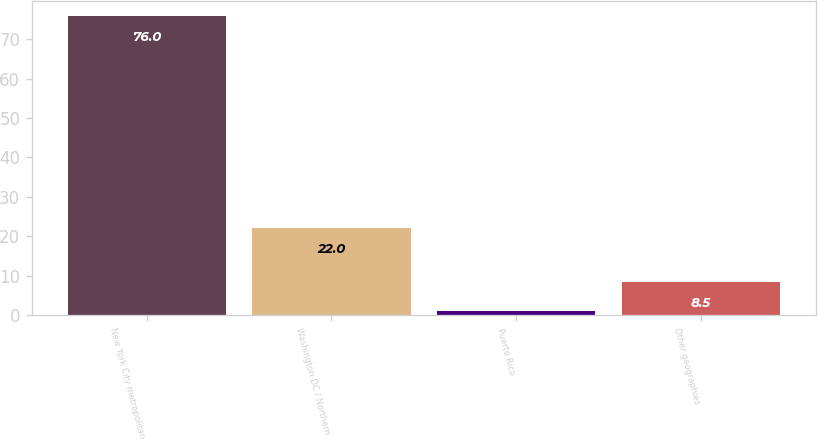Convert chart to OTSL. <chart><loc_0><loc_0><loc_500><loc_500><bar_chart><fcel>New York City metropolitan<fcel>Washington DC / Northern<fcel>Puerto Rico<fcel>Other geographies<nl><fcel>76<fcel>22<fcel>1<fcel>8.5<nl></chart> 